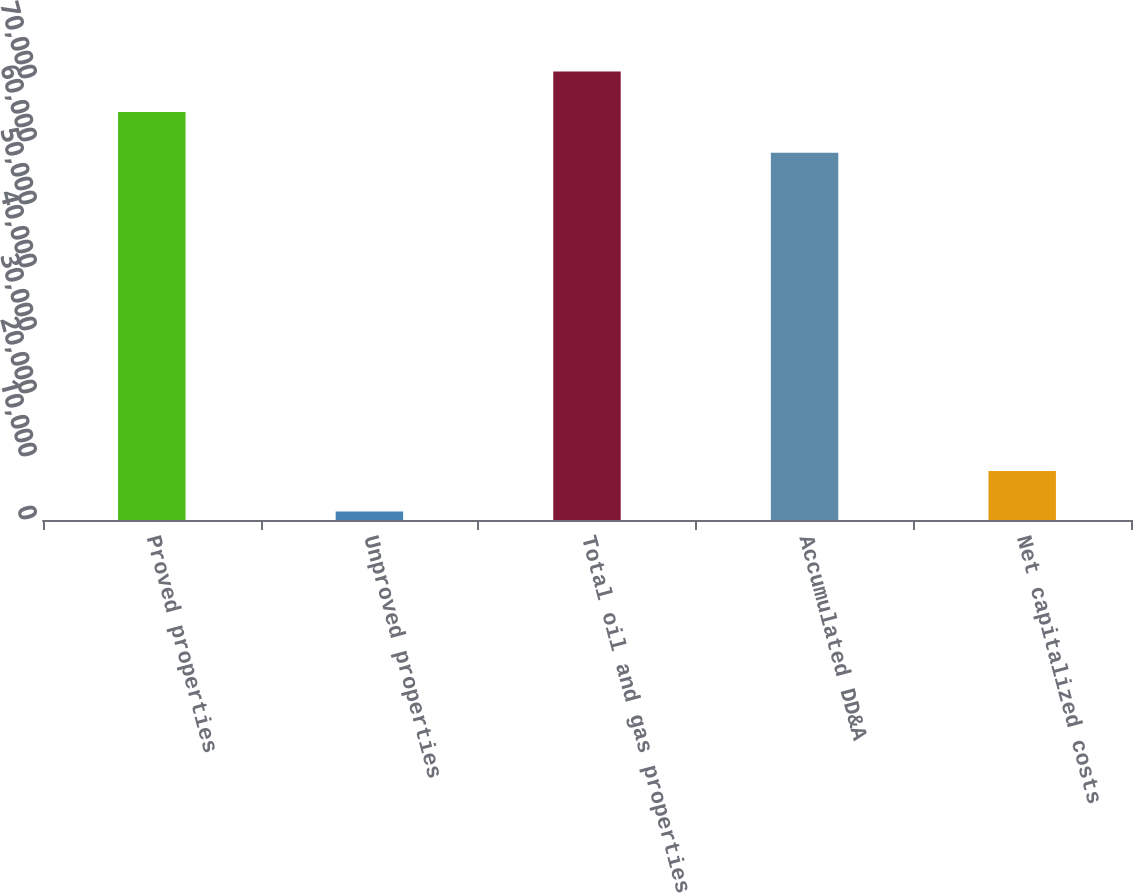Convert chart. <chart><loc_0><loc_0><loc_500><loc_500><bar_chart><fcel>Proved properties<fcel>Unproved properties<fcel>Total oil and gas properties<fcel>Accumulated DD&A<fcel>Net capitalized costs<nl><fcel>64756.3<fcel>1352<fcel>71200.6<fcel>58312<fcel>7796.3<nl></chart> 